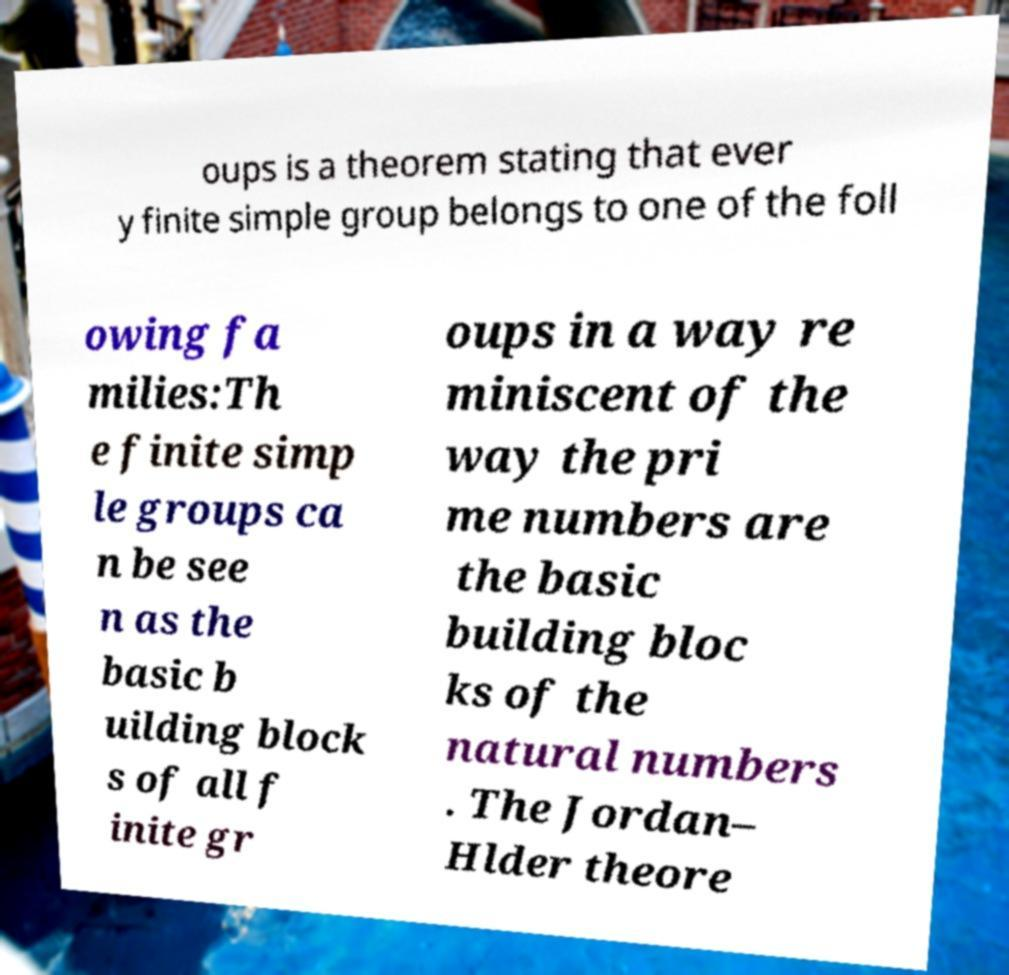Please read and relay the text visible in this image. What does it say? oups is a theorem stating that ever y finite simple group belongs to one of the foll owing fa milies:Th e finite simp le groups ca n be see n as the basic b uilding block s of all f inite gr oups in a way re miniscent of the way the pri me numbers are the basic building bloc ks of the natural numbers . The Jordan– Hlder theore 